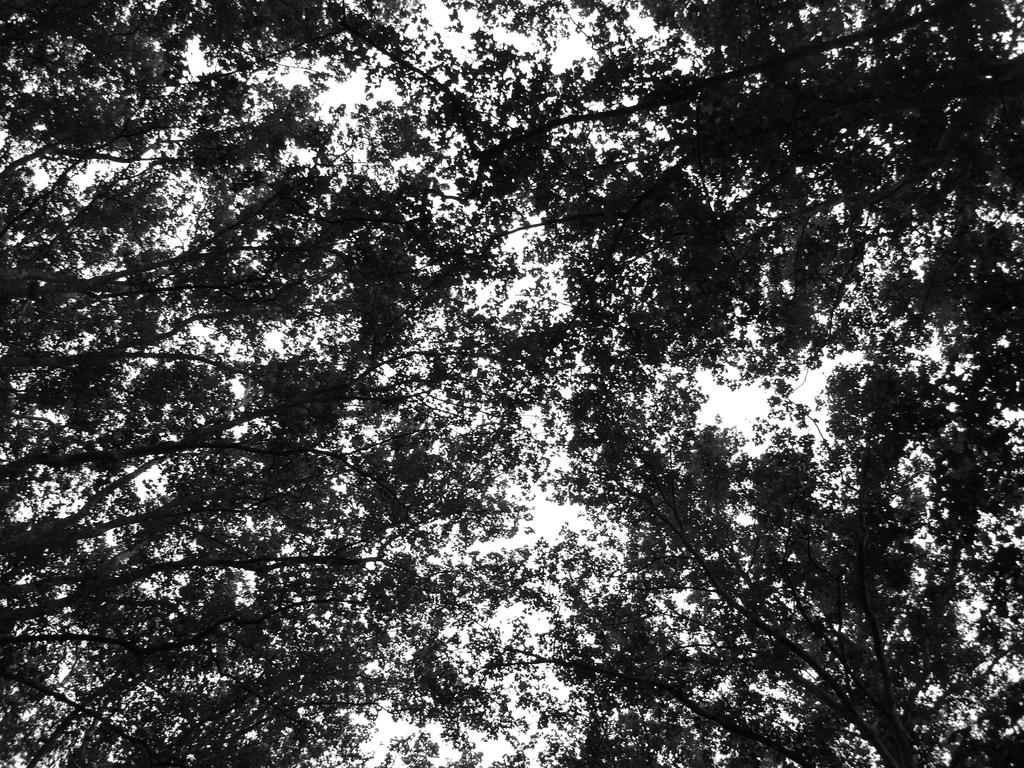What type of vegetation can be seen in the image? There are trees in the image. What part of the natural environment is visible in the background of the image? The sky is visible in the background of the image. What type of tool is being used to dig in the dirt in the image? There is no tool or dirt present in the image; it only features trees and the sky. 